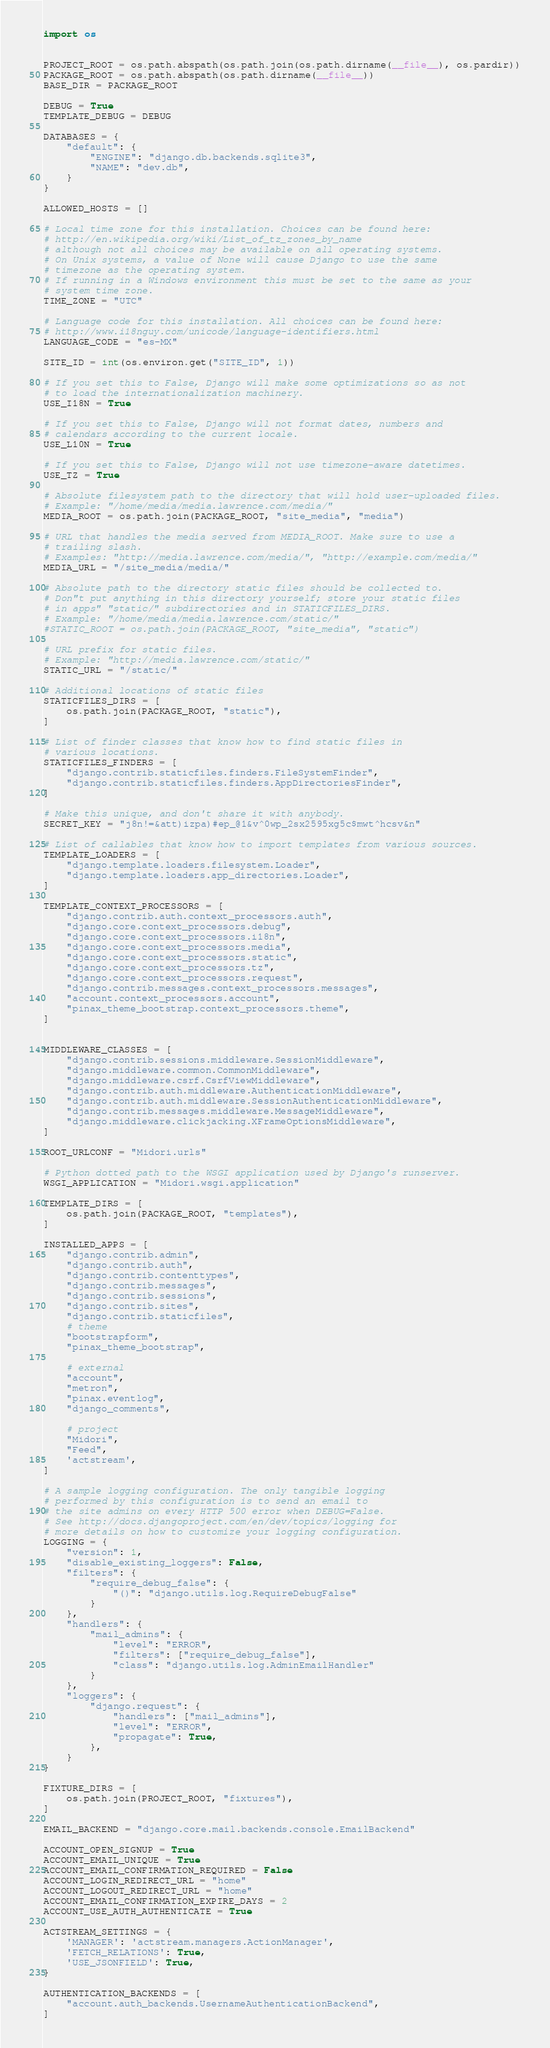Convert code to text. <code><loc_0><loc_0><loc_500><loc_500><_Python_>import os


PROJECT_ROOT = os.path.abspath(os.path.join(os.path.dirname(__file__), os.pardir))
PACKAGE_ROOT = os.path.abspath(os.path.dirname(__file__))
BASE_DIR = PACKAGE_ROOT

DEBUG = True
TEMPLATE_DEBUG = DEBUG

DATABASES = {
    "default": {
        "ENGINE": "django.db.backends.sqlite3",
        "NAME": "dev.db",
    }
}

ALLOWED_HOSTS = []

# Local time zone for this installation. Choices can be found here:
# http://en.wikipedia.org/wiki/List_of_tz_zones_by_name
# although not all choices may be available on all operating systems.
# On Unix systems, a value of None will cause Django to use the same
# timezone as the operating system.
# If running in a Windows environment this must be set to the same as your
# system time zone.
TIME_ZONE = "UTC"

# Language code for this installation. All choices can be found here:
# http://www.i18nguy.com/unicode/language-identifiers.html
LANGUAGE_CODE = "es-MX"

SITE_ID = int(os.environ.get("SITE_ID", 1))

# If you set this to False, Django will make some optimizations so as not
# to load the internationalization machinery.
USE_I18N = True

# If you set this to False, Django will not format dates, numbers and
# calendars according to the current locale.
USE_L10N = True

# If you set this to False, Django will not use timezone-aware datetimes.
USE_TZ = True

# Absolute filesystem path to the directory that will hold user-uploaded files.
# Example: "/home/media/media.lawrence.com/media/"
MEDIA_ROOT = os.path.join(PACKAGE_ROOT, "site_media", "media")

# URL that handles the media served from MEDIA_ROOT. Make sure to use a
# trailing slash.
# Examples: "http://media.lawrence.com/media/", "http://example.com/media/"
MEDIA_URL = "/site_media/media/"

# Absolute path to the directory static files should be collected to.
# Don"t put anything in this directory yourself; store your static files
# in apps" "static/" subdirectories and in STATICFILES_DIRS.
# Example: "/home/media/media.lawrence.com/static/"
#STATIC_ROOT = os.path.join(PACKAGE_ROOT, "site_media", "static")

# URL prefix for static files.
# Example: "http://media.lawrence.com/static/"
STATIC_URL = "/static/"

# Additional locations of static files
STATICFILES_DIRS = [
    os.path.join(PACKAGE_ROOT, "static"),
]

# List of finder classes that know how to find static files in
# various locations.
STATICFILES_FINDERS = [
    "django.contrib.staticfiles.finders.FileSystemFinder",
    "django.contrib.staticfiles.finders.AppDirectoriesFinder",
]

# Make this unique, and don't share it with anybody.
SECRET_KEY = "j8n!=&att)izpa)#ep_@1&v^0wp_2sx2595xg5c$mwt^hcsv&n"

# List of callables that know how to import templates from various sources.
TEMPLATE_LOADERS = [
    "django.template.loaders.filesystem.Loader",
    "django.template.loaders.app_directories.Loader",
]

TEMPLATE_CONTEXT_PROCESSORS = [
    "django.contrib.auth.context_processors.auth",
    "django.core.context_processors.debug",
    "django.core.context_processors.i18n",
    "django.core.context_processors.media",
    "django.core.context_processors.static",
    "django.core.context_processors.tz",
    "django.core.context_processors.request",
    "django.contrib.messages.context_processors.messages",
    "account.context_processors.account",
    "pinax_theme_bootstrap.context_processors.theme",
]


MIDDLEWARE_CLASSES = [
    "django.contrib.sessions.middleware.SessionMiddleware",
    "django.middleware.common.CommonMiddleware",
    "django.middleware.csrf.CsrfViewMiddleware",
    "django.contrib.auth.middleware.AuthenticationMiddleware",
    "django.contrib.auth.middleware.SessionAuthenticationMiddleware",
    "django.contrib.messages.middleware.MessageMiddleware",
    "django.middleware.clickjacking.XFrameOptionsMiddleware",
]

ROOT_URLCONF = "Midori.urls"

# Python dotted path to the WSGI application used by Django's runserver.
WSGI_APPLICATION = "Midori.wsgi.application"

TEMPLATE_DIRS = [
    os.path.join(PACKAGE_ROOT, "templates"),
]

INSTALLED_APPS = [
    "django.contrib.admin",
    "django.contrib.auth",
    "django.contrib.contenttypes",
    "django.contrib.messages",
    "django.contrib.sessions",
    "django.contrib.sites",
    "django.contrib.staticfiles",
    # theme
    "bootstrapform",
    "pinax_theme_bootstrap",

    # external
    "account",
    "metron",
    "pinax.eventlog",
    "django_comments",

    # project
    "Midori",
    "Feed",
    'actstream',
]

# A sample logging configuration. The only tangible logging
# performed by this configuration is to send an email to
# the site admins on every HTTP 500 error when DEBUG=False.
# See http://docs.djangoproject.com/en/dev/topics/logging for
# more details on how to customize your logging configuration.
LOGGING = {
    "version": 1,
    "disable_existing_loggers": False,
    "filters": {
        "require_debug_false": {
            "()": "django.utils.log.RequireDebugFalse"
        }
    },
    "handlers": {
        "mail_admins": {
            "level": "ERROR",
            "filters": ["require_debug_false"],
            "class": "django.utils.log.AdminEmailHandler"
        }
    },
    "loggers": {
        "django.request": {
            "handlers": ["mail_admins"],
            "level": "ERROR",
            "propagate": True,
        },
    }
}

FIXTURE_DIRS = [
    os.path.join(PROJECT_ROOT, "fixtures"),
]

EMAIL_BACKEND = "django.core.mail.backends.console.EmailBackend"

ACCOUNT_OPEN_SIGNUP = True
ACCOUNT_EMAIL_UNIQUE = True
ACCOUNT_EMAIL_CONFIRMATION_REQUIRED = False
ACCOUNT_LOGIN_REDIRECT_URL = "home"
ACCOUNT_LOGOUT_REDIRECT_URL = "home"
ACCOUNT_EMAIL_CONFIRMATION_EXPIRE_DAYS = 2
ACCOUNT_USE_AUTH_AUTHENTICATE = True

ACTSTREAM_SETTINGS = {
    'MANAGER': 'actstream.managers.ActionManager',
    'FETCH_RELATIONS': True,
    'USE_JSONFIELD': True,
}

AUTHENTICATION_BACKENDS = [
    "account.auth_backends.UsernameAuthenticationBackend",
]
</code> 